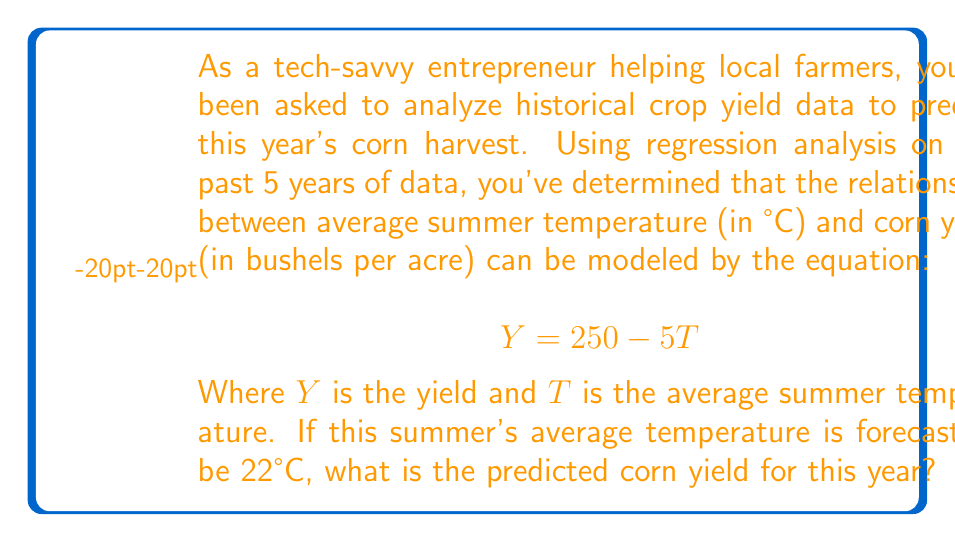Provide a solution to this math problem. To solve this problem, we'll follow these steps:

1. Understand the given equation:
   The equation $Y = 250 - 5T$ represents a linear regression model where:
   - $Y$ is the dependent variable (corn yield in bushels per acre)
   - $T$ is the independent variable (average summer temperature in °C)
   - 250 is the y-intercept
   - -5 is the slope, indicating that for each 1°C increase in temperature, the yield decreases by 5 bushels per acre

2. Identify the given information:
   - The forecast average summer temperature is 22°C

3. Substitute the given temperature into the equation:
   $$Y = 250 - 5T$$
   $$Y = 250 - 5(22)$$

4. Solve the equation:
   $$Y = 250 - 110$$
   $$Y = 140$$

Therefore, the predicted corn yield for this year is 140 bushels per acre.
Answer: 140 bushels per acre 